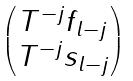Convert formula to latex. <formula><loc_0><loc_0><loc_500><loc_500>\begin{pmatrix} T ^ { - j } f _ { l - j } \\ T ^ { - j } s _ { l - j } \end{pmatrix}</formula> 